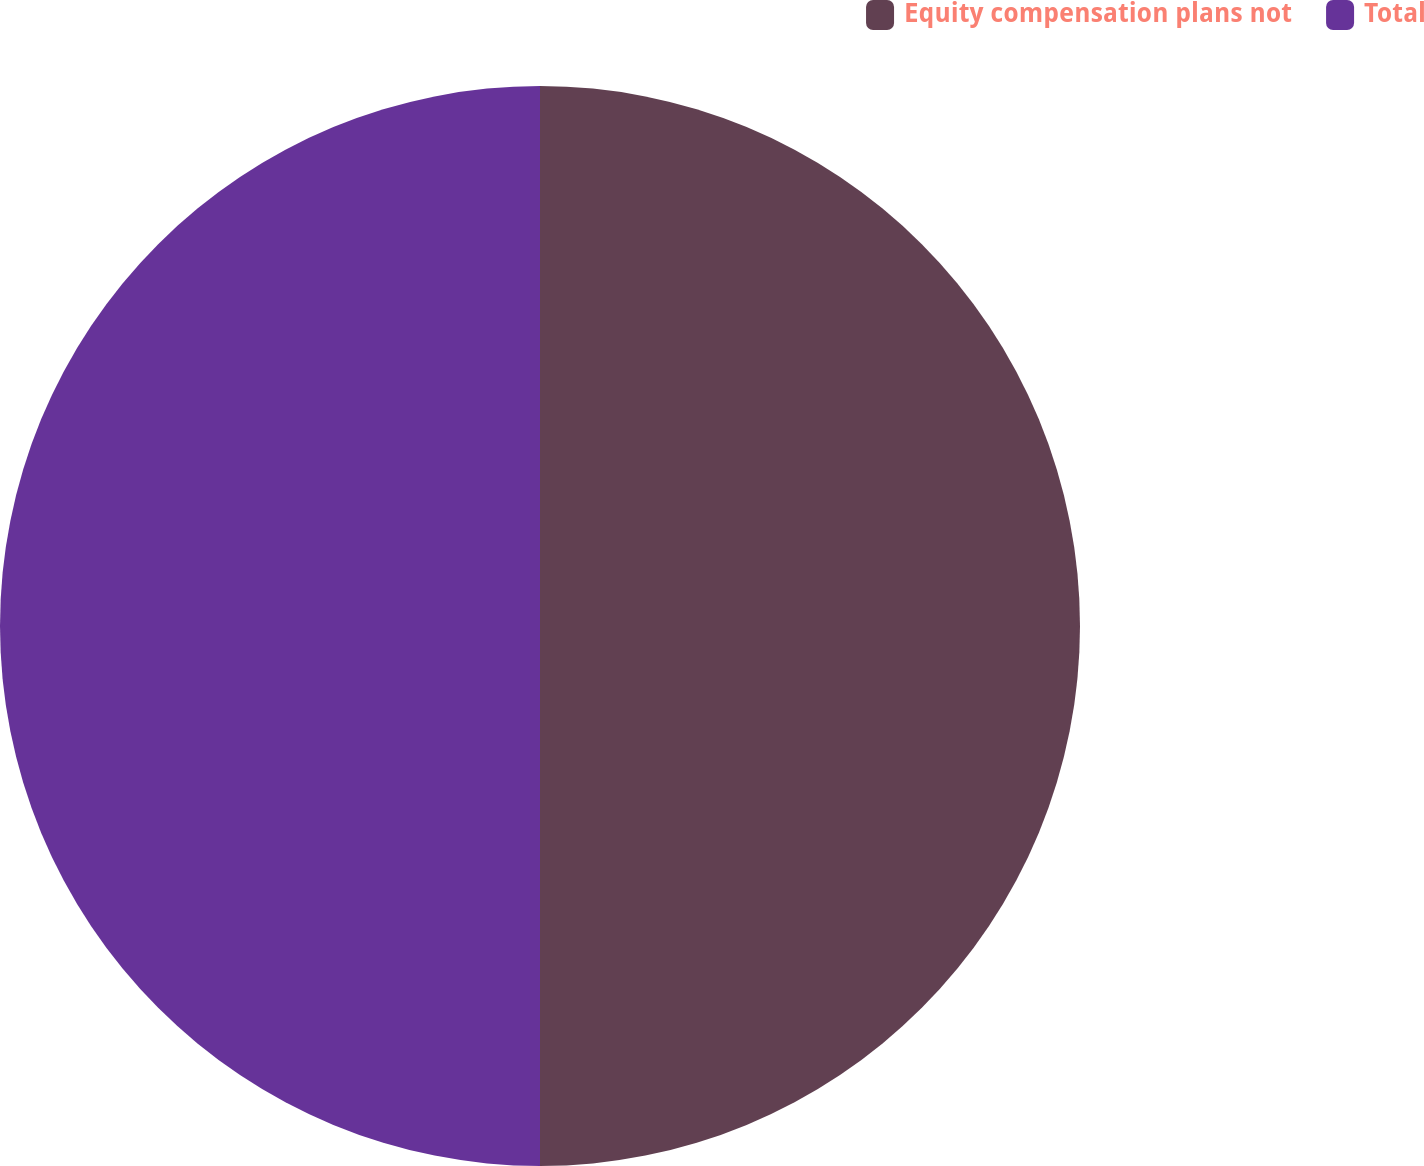Convert chart to OTSL. <chart><loc_0><loc_0><loc_500><loc_500><pie_chart><fcel>Equity compensation plans not<fcel>Total<nl><fcel>50.0%<fcel>50.0%<nl></chart> 